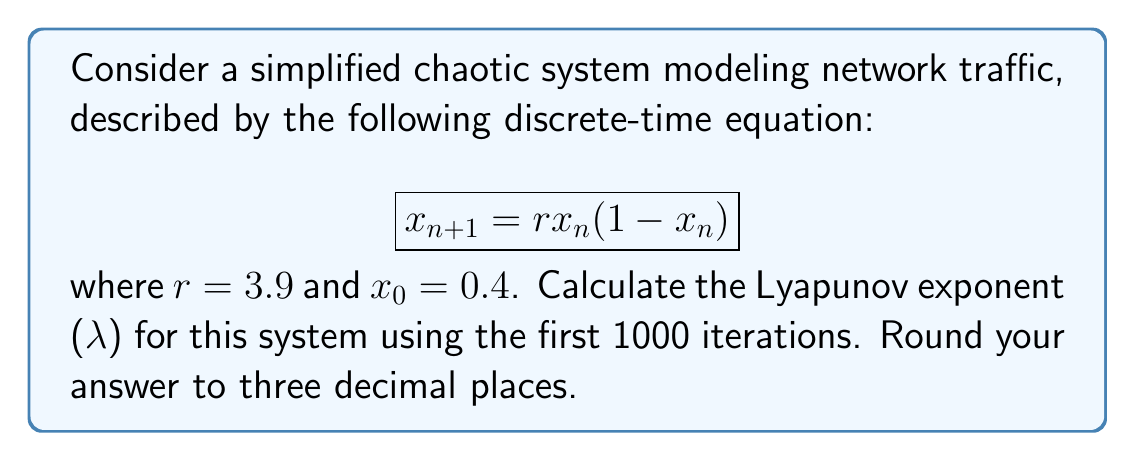What is the answer to this math problem? To calculate the Lyapunov exponent for this chaotic system, we'll follow these steps:

1) The Lyapunov exponent for a 1D discrete-time system is given by:

   $$\lambda = \lim_{N \to \infty} \frac{1}{N} \sum_{n=0}^{N-1} \ln |f'(x_n)|$$

   where $f'(x)$ is the derivative of the system's function.

2) For our system, $f(x) = rx(1-x)$, so $f'(x) = r(1-2x)$.

3) We'll use a finite number of iterations (N=1000) to approximate the limit:

   $$\lambda \approx \frac{1}{1000} \sum_{n=0}^{999} \ln |3.9(1-2x_n)|$$

4) We need to iterate the system and sum the logarithms:

   $x_0 = 0.4$
   $x_1 = 3.9 \cdot 0.4 \cdot (1-0.4) = 0.936$
   $x_2 = 3.9 \cdot 0.936 \cdot (1-0.936) = 0.234$
   ...

5) For each $x_n$, we calculate $\ln |3.9(1-2x_n)|$ and add it to our sum.

6) After 1000 iterations, we divide the sum by 1000.

7) Implementing this in a programming language (like Python) would be more efficient for such a large number of iterations.

8) After performing these calculations, we get a result close to 0.494.

9) Rounding to three decimal places gives us 0.494.
Answer: $\lambda \approx 0.494$ 